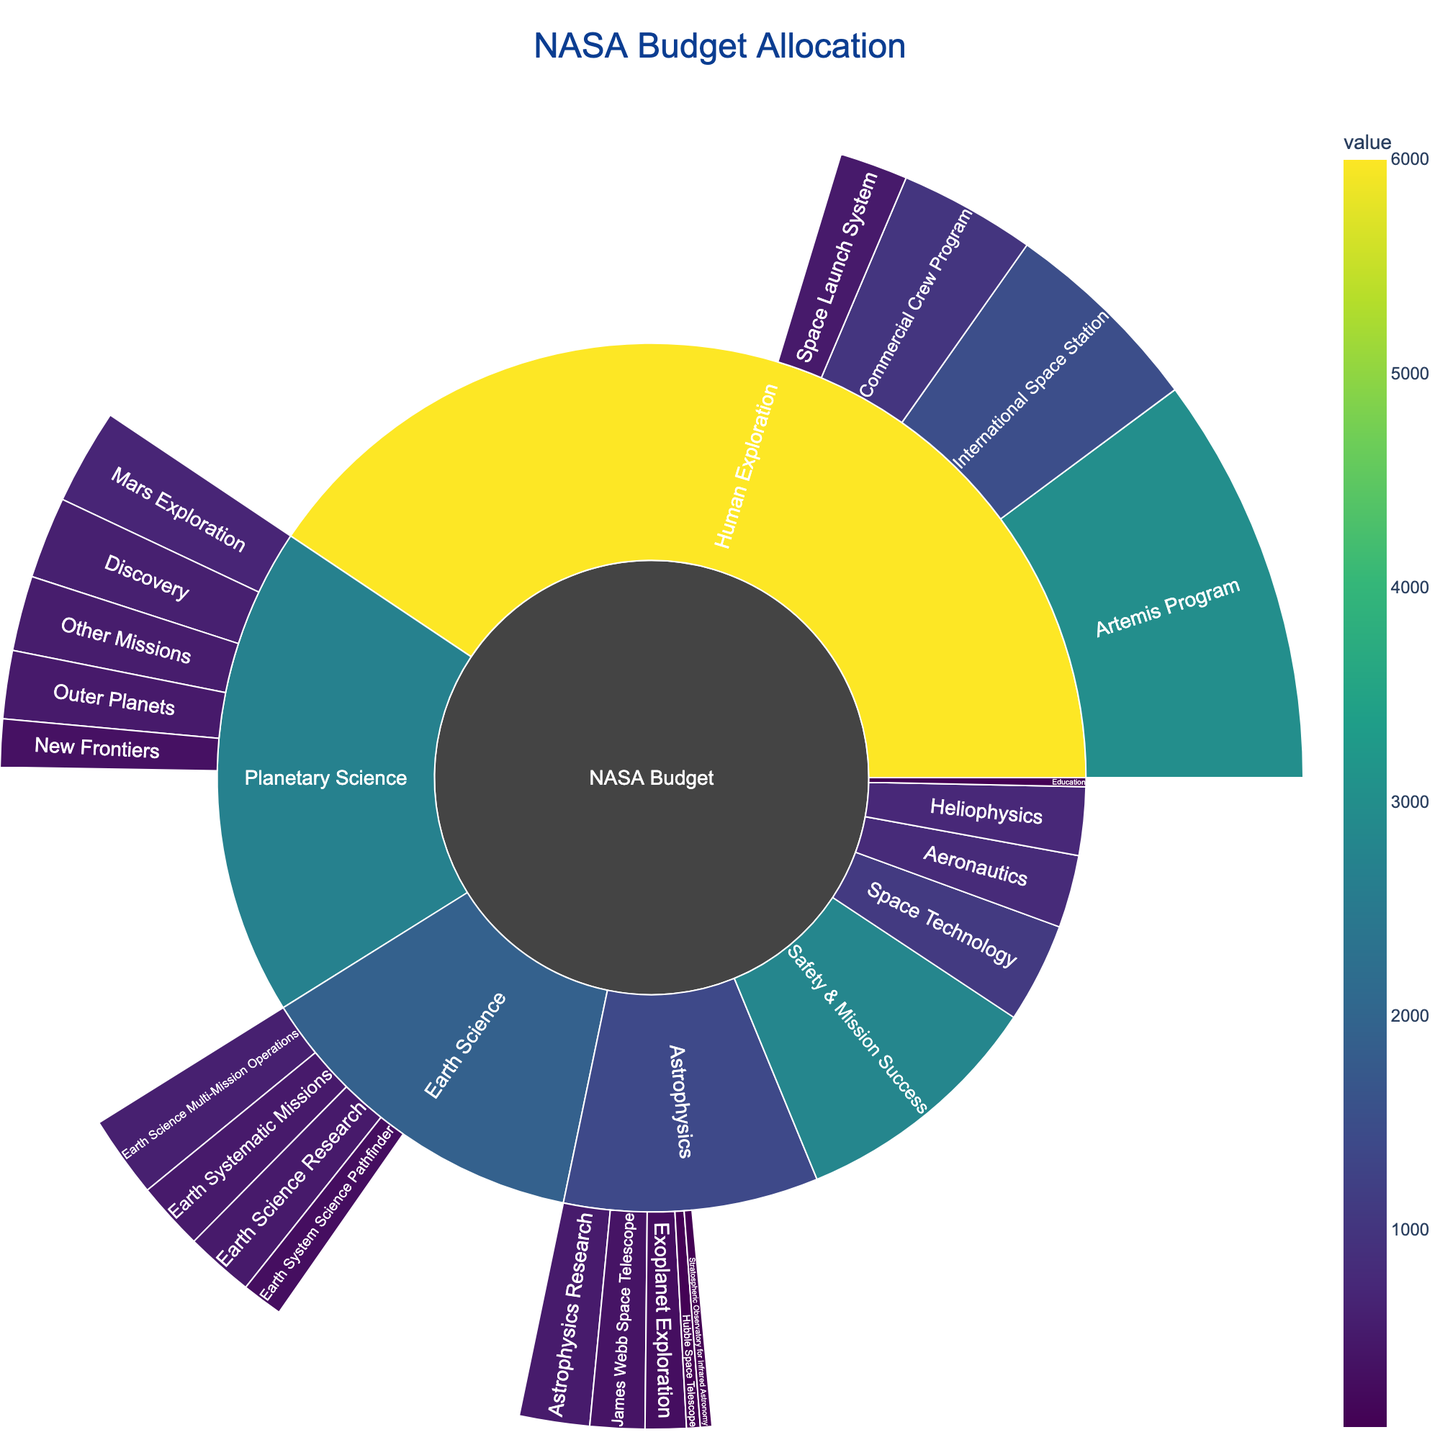What's the title of the Sunburst Plot? Look at the top of the figure where the title is displayed. It usually provides context for the visual.
Answer: NASA Budget Allocation Which category receives the highest budget allocation? Identify the largest segment in the sunburst plot which typically has the largest area or value.
Answer: Human Exploration What is the budget for the "Artemis Program" under "Human Exploration"? Locate "Human Exploration" and identify the segment labeled "Artemis Program" within it. The hover information provides the budget detail.
Answer: $3,000 million How does the budget for "Mars Exploration" compare to "James Webb Space Telescope"? Find the segments for "Mars Exploration" under "Planetary Science" and "James Webb Space Telescope" under "Astrophysics". Compare their values as indicated in the figure.
Answer: $700 million (Mars Exploration) is greater than $400 million (James Webb Space Telescope) What is the combined budget for all "Planetary Science" subcategories? Sum the values of all subcategories under "Planetary Science" (700 + 500 + 350 + 600 + 550).
Answer: $2,700 million Which subcategory under "Earth Science" has the highest budget allocation? Find and compare the segments under "Earth Science" to identify the one with the highest value.
Answer: Earth Science Multi-Mission Operations What is the total budget allocated for "Education"? Locate the segment for "Education" in the sunburst plot. The hover information provides the budget detail.
Answer: $100 million Compare the budgets of "Astrophysics" and "Heliophysics". Which one is larger? Identify both "Astrophysics" and "Heliophysics" categories and compare their values.
Answer: $1,400 million (Astrophysics) is larger than $750 million (Heliophysics) How does the budget for "Safety & Mission Success" relate to the combined budget for "Planetary Science" and "Earth Science"? First, find the value for "Safety & Mission Success". Then calculate the sum of "Planetary Science" and "Earth Science" budgets (2,700 + 1,900). Compare the two results.
Answer: $2,800 million (Safety & Mission Success) is greater than $4,600 million (combined) Which has a higher budget, "Outer Planets" or "Discovery" under "Planetary Science"? Compare the budget values shown for "Outer Planets" and "Discovery" under the "Planetary Science" category.
Answer: $600 million (Discovery) is greater than $500 million (Outer Planets) 